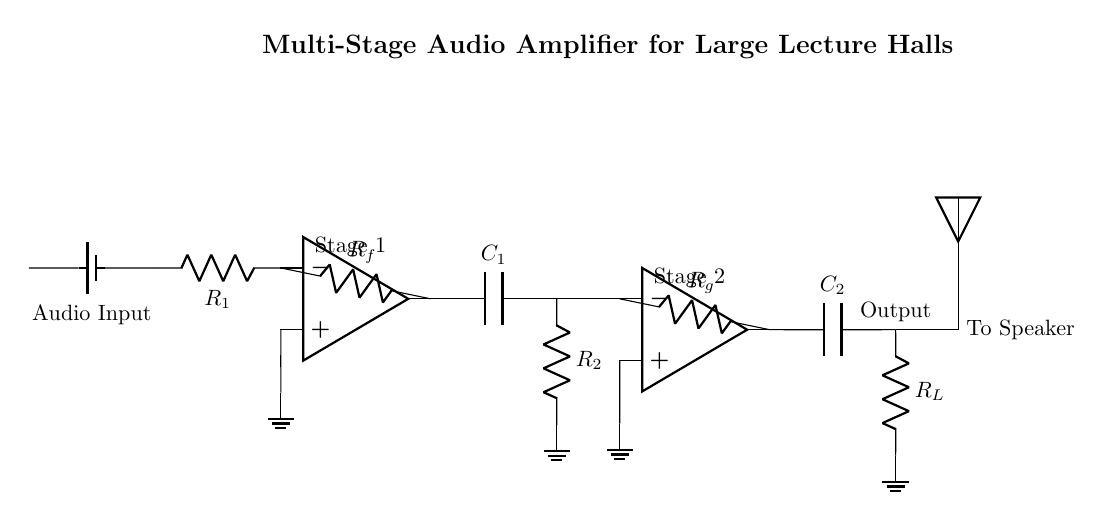What type of circuit is shown in the diagram? The diagram depicts a multi-stage audio amplifier, characterized by its use of operational amplifiers and multiple stages to enhance audio signals.
Answer: multi-stage audio amplifier How many operational amplifiers are there in the circuit? There are two operational amplifiers present in the circuit, each forming a distinct amplification stage for the audio signal.
Answer: two What is the purpose of the capacitor labeled C1? The capacitor C1 is used for coupling, allowing AC signals to pass through while blocking any DC component, thus preserving the integrity of the audio signal.
Answer: coupling What is the function of resistor Rf in the first stage? Resistor Rf serves as a feedback resistor, which helps determine the gain of the first operational amplifier stage by feeding a portion of the output back to the inverting input.
Answer: feedback Which component is responsible for filtering the output signal? The capacitor C2 at the output stage helps filter the audio signal before it is sent to the speaker, smoothing out variations and enhancing audio quality.
Answer: capacitor What effect does increasing the value of resistor R1 have on the gain? Increasing the value of R1 reduces the overall gain of the first stage, as the gain is inversely related to the resistance connected to the inverting input of the operational amplifier.
Answer: reduces gain What connects the output of the second stage to the speaker? The connection from the output of the second stage passes through the load resistor R_L directly to the speaker, facilitating the final delivery of the amplified audio signal.
Answer: load resistor 